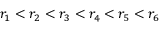Convert formula to latex. <formula><loc_0><loc_0><loc_500><loc_500>r _ { 1 } < r _ { 2 } < r _ { 3 } < r _ { 4 } < r _ { 5 } < r _ { 6 }</formula> 